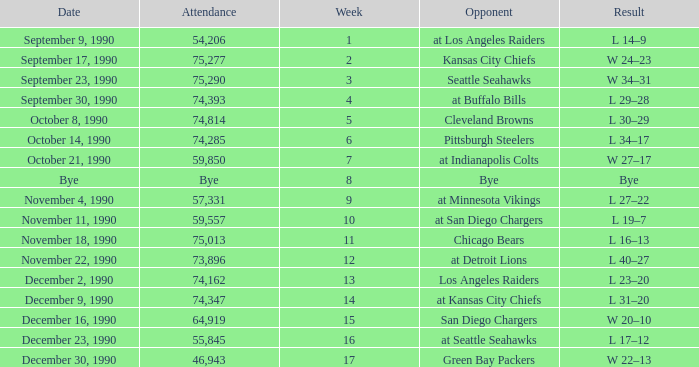What is the latest week with an attendance of 74,162? 13.0. 